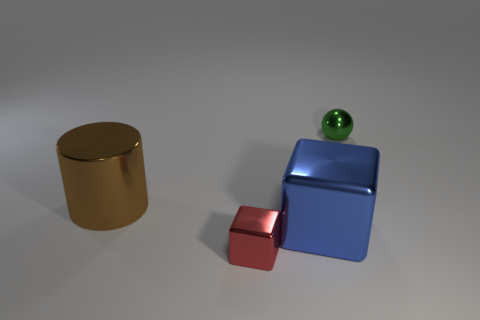Add 3 small shiny balls. How many objects exist? 7 Subtract 1 blocks. How many blocks are left? 1 Subtract all cyan cylinders. How many blue blocks are left? 1 Add 3 big brown objects. How many big brown objects are left? 4 Add 3 large metallic cylinders. How many large metallic cylinders exist? 4 Subtract 0 blue cylinders. How many objects are left? 4 Subtract all blue blocks. Subtract all blue spheres. How many blocks are left? 1 Subtract all red things. Subtract all big blue objects. How many objects are left? 2 